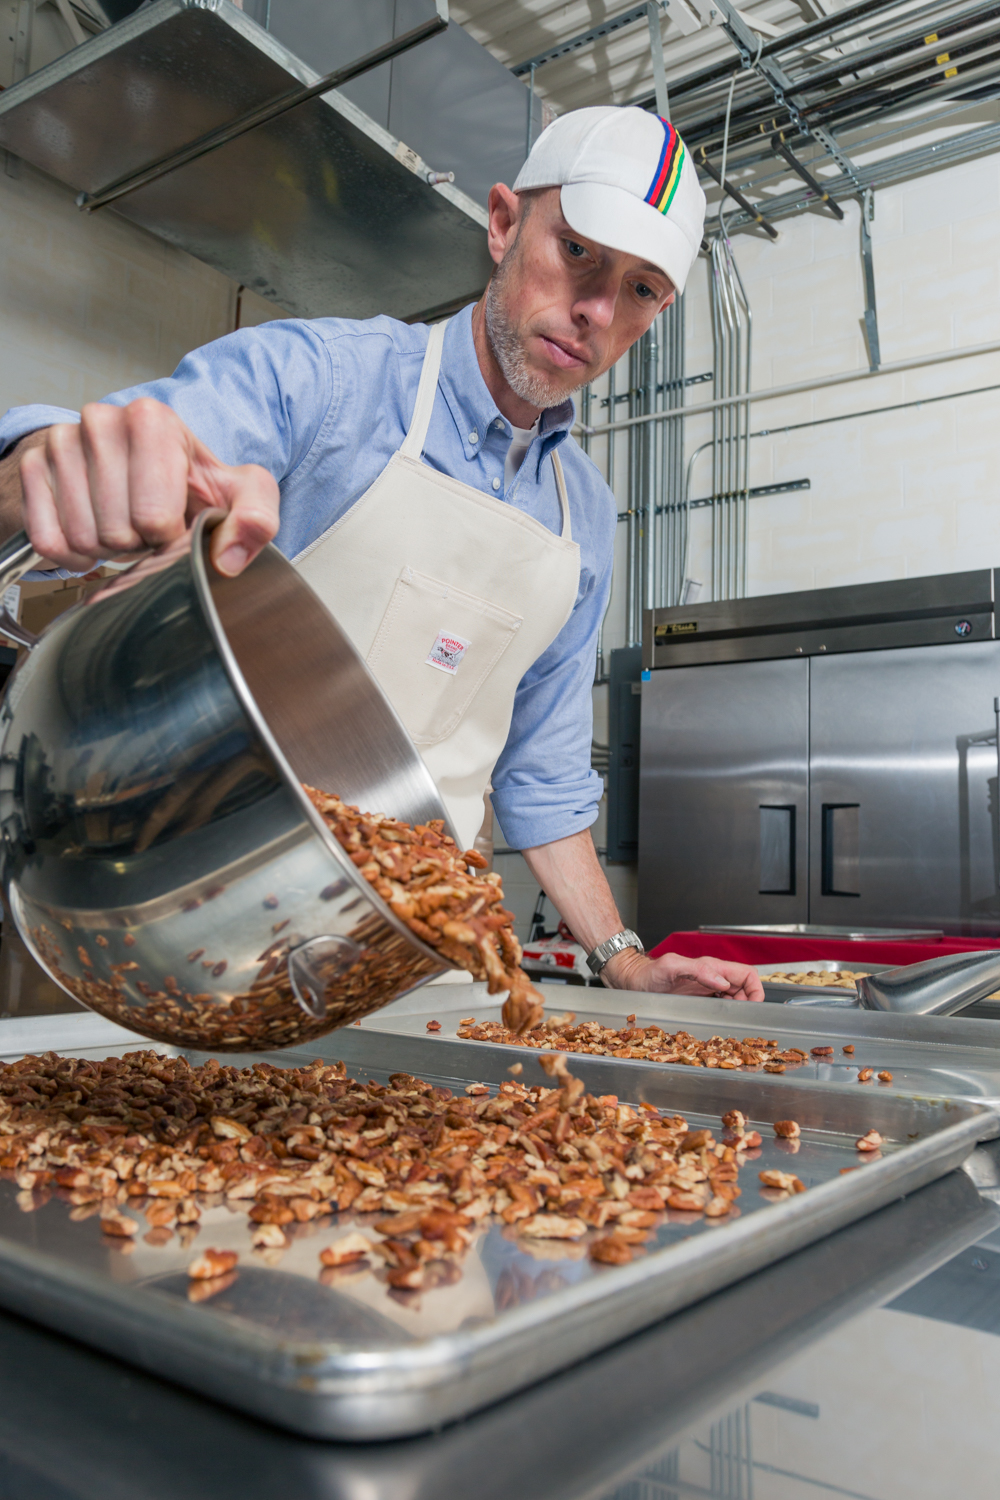What kind of story might unfold if this kitchen were a setting in a mystery novel? If this kitchen were the setting in a mystery novel, it could be the scene of a pivotal event where the protagonist discovers a hidden clue that leads to unraveling a larger conspiracy. Perhaps the commercial-grade equipment and meticulous arrangement were not just for food production but also for concealing secret messages or hidden compartments. The protagonist might uncover a coded message etched into the stainless steel pot, leading them on a thrilling chase through the culinary world to uncover secrets about high-profile clients or mysterious ingredients with unknown origins. The nuts being roasted could even play a role, perhaps containing microfilm or other contraband smuggled under the guise of a gourmet food business. Can you describe a climactic scene in this mystery set in the kitchen? In the climactic scene of the mystery novel set in this kitchen, the protagonist, cornered by the antagonist, ingeniously uses the kitchen equipment to defend themselves. With steam billowing from the industrial oven and the scent of roasted nuts thick in the air, a tense standoff occurs. The protagonist's eye catches the glimmer of a hidden compartment in one of the commercial-grade refrigerators—a repository of vital evidence. With a sudden, strategic move, they fling a tray of hot, freshly roasted nuts to disorient the antagonist, securing enough time to retrieve the evidence. As police sirens blare in the distance, the protagonist cleverly locks the antagonist inside the walk-in freezer, bringing the high-stakes chase to a dramatic conclusion. 